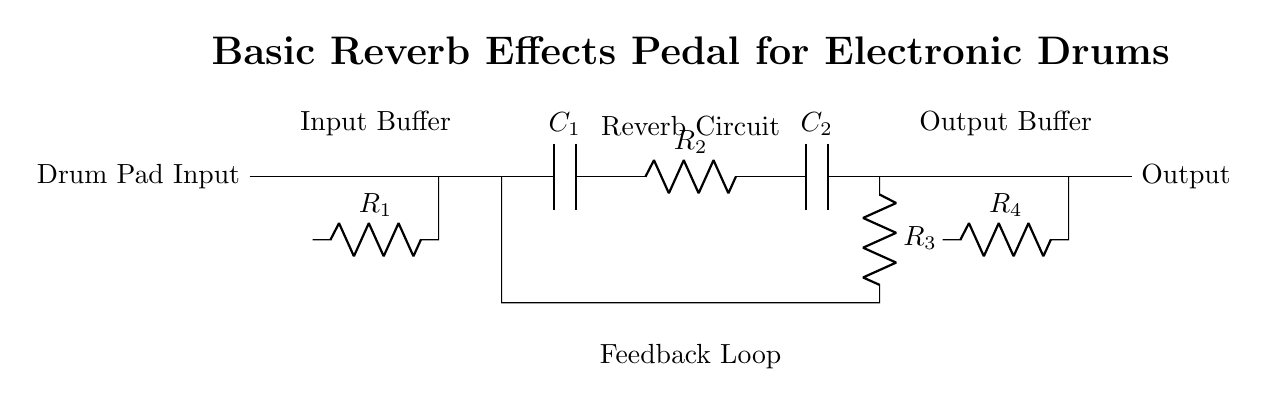What type of circuit is this? This circuit is a basic reverb effects pedal circuit. It is designed specifically for electronic drum pads by adding reverberation to the signal inputted from the drum pads.
Answer: basic reverb effects pedal What is the function of the input buffer? The input buffer is used to isolate the drum pad's signal to prevent loading effects and to ensure that the signal can be processed without distortion. It maintains the integrity of the audio signal before it moves into further stages of the effects pedal.
Answer: isolate signal What components are in the reverb circuit? The reverb circuit contains two capacitors (labeled C1 and C2) and three resistors (labeled R2, R3, and R4). These components work together to create the delay effect necessary for reverb.
Answer: C1, C2, R2, R3, R4 What does the feedback loop do? The feedback loop in this circuit takes the output signal after passing through the reverb components and feeds it back into the circuit. This helps to create the layered effect of reverb by repeating the signal.
Answer: creates reverb How many op-amps are used in the circuit? There are two operational amplifiers used in the circuit. One is used for the input buffer and the other for the output buffer, each amplifying the respective signals to ensure they are strong enough for processing and output.
Answer: two What is the role of resistor R1? Resistor R1 serves as a part of the input buffer to limit the current and set the gain of the operational amplifier. This helps ensure that the signal from the drum pad is appropriately amplified without distortion.
Answer: limit current What is the purpose of the output buffer? The output buffer amplifies the processed signal before sending it out. This ensures that the final signal has sufficient strength to be sent to the next device, such as an amplifier or speaker, while maintaining the quality of the sound.
Answer: amplify signal 